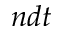<formula> <loc_0><loc_0><loc_500><loc_500>n d t</formula> 